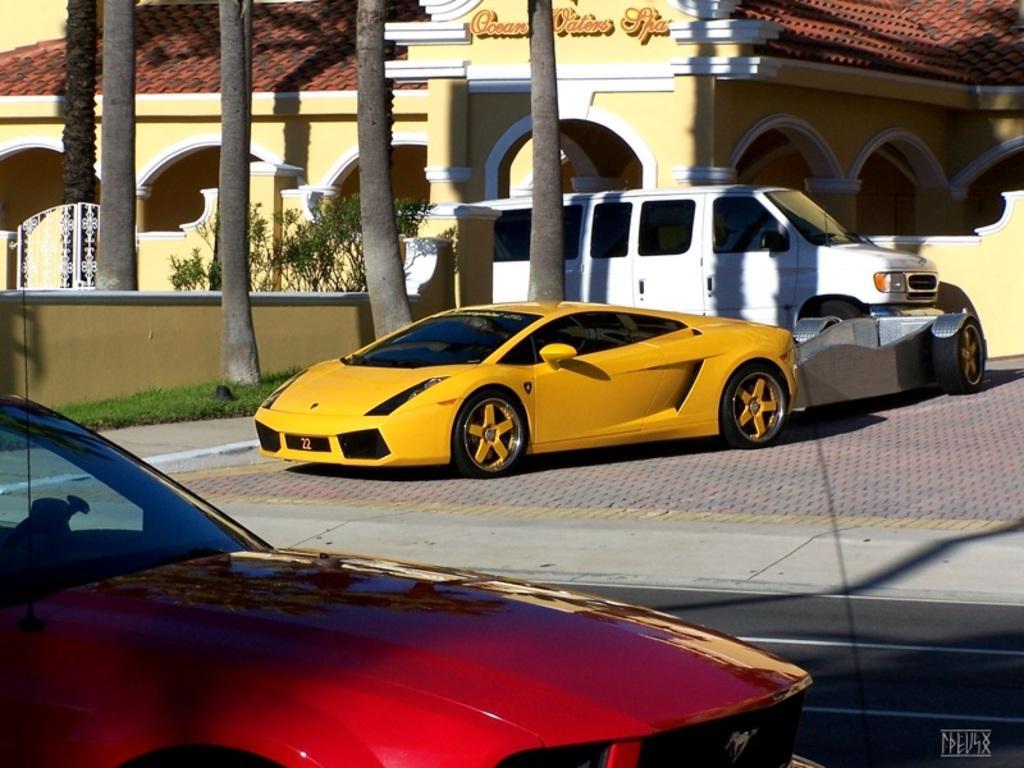Could you give a brief overview of what you see in this image? In the foreground of the image we can see a red color car and a road. In the middle of the image we can see a yellow color car, vehicle and grass. On the top of the image we can see a house and the trunk of the trees. 